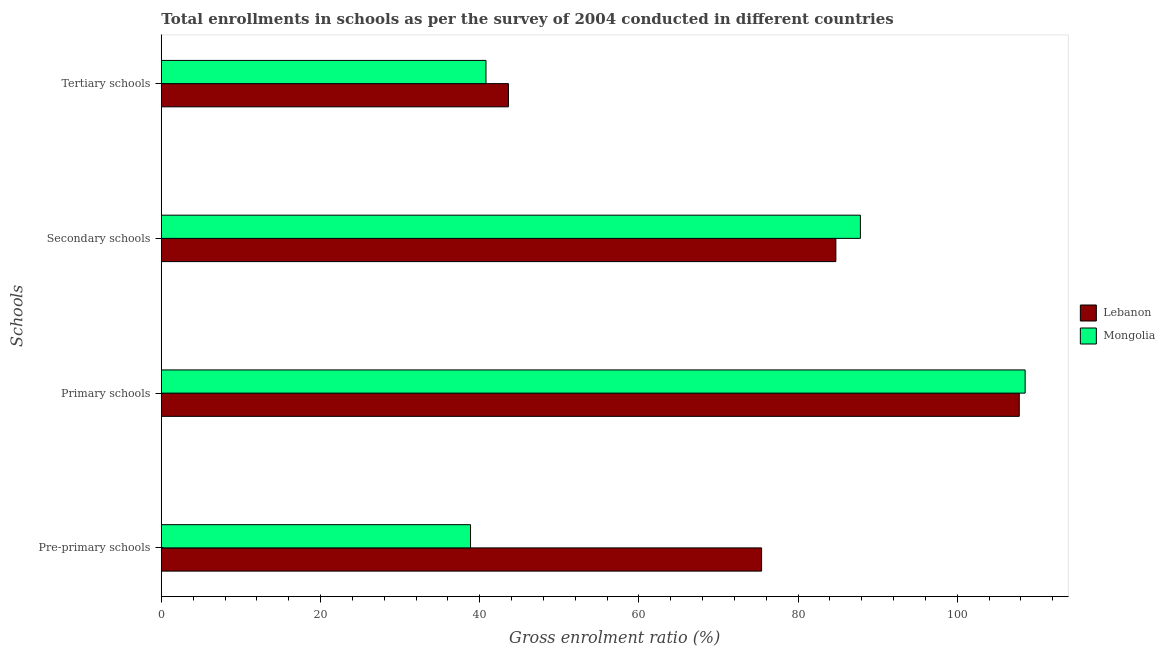How many different coloured bars are there?
Your answer should be very brief. 2. Are the number of bars per tick equal to the number of legend labels?
Keep it short and to the point. Yes. Are the number of bars on each tick of the Y-axis equal?
Your answer should be compact. Yes. What is the label of the 2nd group of bars from the top?
Make the answer very short. Secondary schools. What is the gross enrolment ratio in secondary schools in Mongolia?
Give a very brief answer. 87.83. Across all countries, what is the maximum gross enrolment ratio in primary schools?
Make the answer very short. 108.52. Across all countries, what is the minimum gross enrolment ratio in primary schools?
Make the answer very short. 107.79. In which country was the gross enrolment ratio in primary schools maximum?
Keep it short and to the point. Mongolia. In which country was the gross enrolment ratio in secondary schools minimum?
Offer a very short reply. Lebanon. What is the total gross enrolment ratio in primary schools in the graph?
Give a very brief answer. 216.31. What is the difference between the gross enrolment ratio in primary schools in Lebanon and that in Mongolia?
Make the answer very short. -0.74. What is the difference between the gross enrolment ratio in secondary schools in Lebanon and the gross enrolment ratio in primary schools in Mongolia?
Provide a succinct answer. -23.78. What is the average gross enrolment ratio in tertiary schools per country?
Provide a succinct answer. 42.2. What is the difference between the gross enrolment ratio in tertiary schools and gross enrolment ratio in secondary schools in Mongolia?
Your answer should be compact. -47.04. In how many countries, is the gross enrolment ratio in pre-primary schools greater than 20 %?
Ensure brevity in your answer.  2. What is the ratio of the gross enrolment ratio in pre-primary schools in Lebanon to that in Mongolia?
Provide a succinct answer. 1.94. What is the difference between the highest and the second highest gross enrolment ratio in tertiary schools?
Your answer should be compact. 2.82. What is the difference between the highest and the lowest gross enrolment ratio in secondary schools?
Provide a short and direct response. 3.08. In how many countries, is the gross enrolment ratio in secondary schools greater than the average gross enrolment ratio in secondary schools taken over all countries?
Provide a short and direct response. 1. Is the sum of the gross enrolment ratio in tertiary schools in Lebanon and Mongolia greater than the maximum gross enrolment ratio in secondary schools across all countries?
Your answer should be very brief. No. Is it the case that in every country, the sum of the gross enrolment ratio in primary schools and gross enrolment ratio in secondary schools is greater than the sum of gross enrolment ratio in tertiary schools and gross enrolment ratio in pre-primary schools?
Offer a very short reply. Yes. What does the 2nd bar from the top in Primary schools represents?
Offer a very short reply. Lebanon. What does the 1st bar from the bottom in Secondary schools represents?
Ensure brevity in your answer.  Lebanon. Is it the case that in every country, the sum of the gross enrolment ratio in pre-primary schools and gross enrolment ratio in primary schools is greater than the gross enrolment ratio in secondary schools?
Make the answer very short. Yes. How many bars are there?
Make the answer very short. 8. How many countries are there in the graph?
Ensure brevity in your answer.  2. How many legend labels are there?
Give a very brief answer. 2. How are the legend labels stacked?
Provide a succinct answer. Vertical. What is the title of the graph?
Your answer should be very brief. Total enrollments in schools as per the survey of 2004 conducted in different countries. Does "World" appear as one of the legend labels in the graph?
Offer a terse response. No. What is the label or title of the X-axis?
Give a very brief answer. Gross enrolment ratio (%). What is the label or title of the Y-axis?
Provide a succinct answer. Schools. What is the Gross enrolment ratio (%) in Lebanon in Pre-primary schools?
Your response must be concise. 75.41. What is the Gross enrolment ratio (%) of Mongolia in Pre-primary schools?
Make the answer very short. 38.85. What is the Gross enrolment ratio (%) in Lebanon in Primary schools?
Your response must be concise. 107.79. What is the Gross enrolment ratio (%) of Mongolia in Primary schools?
Provide a succinct answer. 108.52. What is the Gross enrolment ratio (%) in Lebanon in Secondary schools?
Your response must be concise. 84.74. What is the Gross enrolment ratio (%) of Mongolia in Secondary schools?
Your answer should be very brief. 87.83. What is the Gross enrolment ratio (%) in Lebanon in Tertiary schools?
Offer a very short reply. 43.61. What is the Gross enrolment ratio (%) in Mongolia in Tertiary schools?
Keep it short and to the point. 40.79. Across all Schools, what is the maximum Gross enrolment ratio (%) of Lebanon?
Provide a short and direct response. 107.79. Across all Schools, what is the maximum Gross enrolment ratio (%) in Mongolia?
Make the answer very short. 108.52. Across all Schools, what is the minimum Gross enrolment ratio (%) of Lebanon?
Keep it short and to the point. 43.61. Across all Schools, what is the minimum Gross enrolment ratio (%) of Mongolia?
Provide a short and direct response. 38.85. What is the total Gross enrolment ratio (%) in Lebanon in the graph?
Keep it short and to the point. 311.55. What is the total Gross enrolment ratio (%) of Mongolia in the graph?
Offer a very short reply. 275.99. What is the difference between the Gross enrolment ratio (%) in Lebanon in Pre-primary schools and that in Primary schools?
Make the answer very short. -32.37. What is the difference between the Gross enrolment ratio (%) in Mongolia in Pre-primary schools and that in Primary schools?
Offer a terse response. -69.68. What is the difference between the Gross enrolment ratio (%) of Lebanon in Pre-primary schools and that in Secondary schools?
Offer a very short reply. -9.33. What is the difference between the Gross enrolment ratio (%) of Mongolia in Pre-primary schools and that in Secondary schools?
Keep it short and to the point. -48.98. What is the difference between the Gross enrolment ratio (%) of Lebanon in Pre-primary schools and that in Tertiary schools?
Offer a very short reply. 31.8. What is the difference between the Gross enrolment ratio (%) of Mongolia in Pre-primary schools and that in Tertiary schools?
Provide a short and direct response. -1.94. What is the difference between the Gross enrolment ratio (%) of Lebanon in Primary schools and that in Secondary schools?
Make the answer very short. 23.04. What is the difference between the Gross enrolment ratio (%) in Mongolia in Primary schools and that in Secondary schools?
Offer a terse response. 20.7. What is the difference between the Gross enrolment ratio (%) in Lebanon in Primary schools and that in Tertiary schools?
Your response must be concise. 64.18. What is the difference between the Gross enrolment ratio (%) of Mongolia in Primary schools and that in Tertiary schools?
Make the answer very short. 67.74. What is the difference between the Gross enrolment ratio (%) of Lebanon in Secondary schools and that in Tertiary schools?
Make the answer very short. 41.13. What is the difference between the Gross enrolment ratio (%) of Mongolia in Secondary schools and that in Tertiary schools?
Ensure brevity in your answer.  47.04. What is the difference between the Gross enrolment ratio (%) in Lebanon in Pre-primary schools and the Gross enrolment ratio (%) in Mongolia in Primary schools?
Make the answer very short. -33.11. What is the difference between the Gross enrolment ratio (%) in Lebanon in Pre-primary schools and the Gross enrolment ratio (%) in Mongolia in Secondary schools?
Keep it short and to the point. -12.41. What is the difference between the Gross enrolment ratio (%) in Lebanon in Pre-primary schools and the Gross enrolment ratio (%) in Mongolia in Tertiary schools?
Provide a succinct answer. 34.62. What is the difference between the Gross enrolment ratio (%) in Lebanon in Primary schools and the Gross enrolment ratio (%) in Mongolia in Secondary schools?
Give a very brief answer. 19.96. What is the difference between the Gross enrolment ratio (%) in Lebanon in Primary schools and the Gross enrolment ratio (%) in Mongolia in Tertiary schools?
Give a very brief answer. 67. What is the difference between the Gross enrolment ratio (%) of Lebanon in Secondary schools and the Gross enrolment ratio (%) of Mongolia in Tertiary schools?
Provide a succinct answer. 43.95. What is the average Gross enrolment ratio (%) in Lebanon per Schools?
Your response must be concise. 77.89. What is the average Gross enrolment ratio (%) in Mongolia per Schools?
Your response must be concise. 69. What is the difference between the Gross enrolment ratio (%) in Lebanon and Gross enrolment ratio (%) in Mongolia in Pre-primary schools?
Ensure brevity in your answer.  36.57. What is the difference between the Gross enrolment ratio (%) in Lebanon and Gross enrolment ratio (%) in Mongolia in Primary schools?
Your answer should be very brief. -0.74. What is the difference between the Gross enrolment ratio (%) of Lebanon and Gross enrolment ratio (%) of Mongolia in Secondary schools?
Provide a succinct answer. -3.08. What is the difference between the Gross enrolment ratio (%) in Lebanon and Gross enrolment ratio (%) in Mongolia in Tertiary schools?
Provide a succinct answer. 2.82. What is the ratio of the Gross enrolment ratio (%) of Lebanon in Pre-primary schools to that in Primary schools?
Your answer should be very brief. 0.7. What is the ratio of the Gross enrolment ratio (%) in Mongolia in Pre-primary schools to that in Primary schools?
Provide a short and direct response. 0.36. What is the ratio of the Gross enrolment ratio (%) of Lebanon in Pre-primary schools to that in Secondary schools?
Offer a terse response. 0.89. What is the ratio of the Gross enrolment ratio (%) of Mongolia in Pre-primary schools to that in Secondary schools?
Your response must be concise. 0.44. What is the ratio of the Gross enrolment ratio (%) in Lebanon in Pre-primary schools to that in Tertiary schools?
Offer a very short reply. 1.73. What is the ratio of the Gross enrolment ratio (%) of Mongolia in Pre-primary schools to that in Tertiary schools?
Provide a short and direct response. 0.95. What is the ratio of the Gross enrolment ratio (%) of Lebanon in Primary schools to that in Secondary schools?
Make the answer very short. 1.27. What is the ratio of the Gross enrolment ratio (%) in Mongolia in Primary schools to that in Secondary schools?
Ensure brevity in your answer.  1.24. What is the ratio of the Gross enrolment ratio (%) of Lebanon in Primary schools to that in Tertiary schools?
Make the answer very short. 2.47. What is the ratio of the Gross enrolment ratio (%) of Mongolia in Primary schools to that in Tertiary schools?
Offer a very short reply. 2.66. What is the ratio of the Gross enrolment ratio (%) in Lebanon in Secondary schools to that in Tertiary schools?
Ensure brevity in your answer.  1.94. What is the ratio of the Gross enrolment ratio (%) of Mongolia in Secondary schools to that in Tertiary schools?
Ensure brevity in your answer.  2.15. What is the difference between the highest and the second highest Gross enrolment ratio (%) in Lebanon?
Give a very brief answer. 23.04. What is the difference between the highest and the second highest Gross enrolment ratio (%) in Mongolia?
Provide a succinct answer. 20.7. What is the difference between the highest and the lowest Gross enrolment ratio (%) in Lebanon?
Provide a succinct answer. 64.18. What is the difference between the highest and the lowest Gross enrolment ratio (%) in Mongolia?
Offer a very short reply. 69.68. 